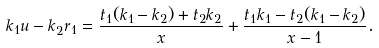Convert formula to latex. <formula><loc_0><loc_0><loc_500><loc_500>k _ { 1 } u - k _ { 2 } r _ { 1 } = \frac { t _ { 1 } ( k _ { 1 } - k _ { 2 } ) + t _ { 2 } k _ { 2 } } { x } + \frac { t _ { 1 } k _ { 1 } - t _ { 2 } ( k _ { 1 } - k _ { 2 } ) } { x - 1 } .</formula> 